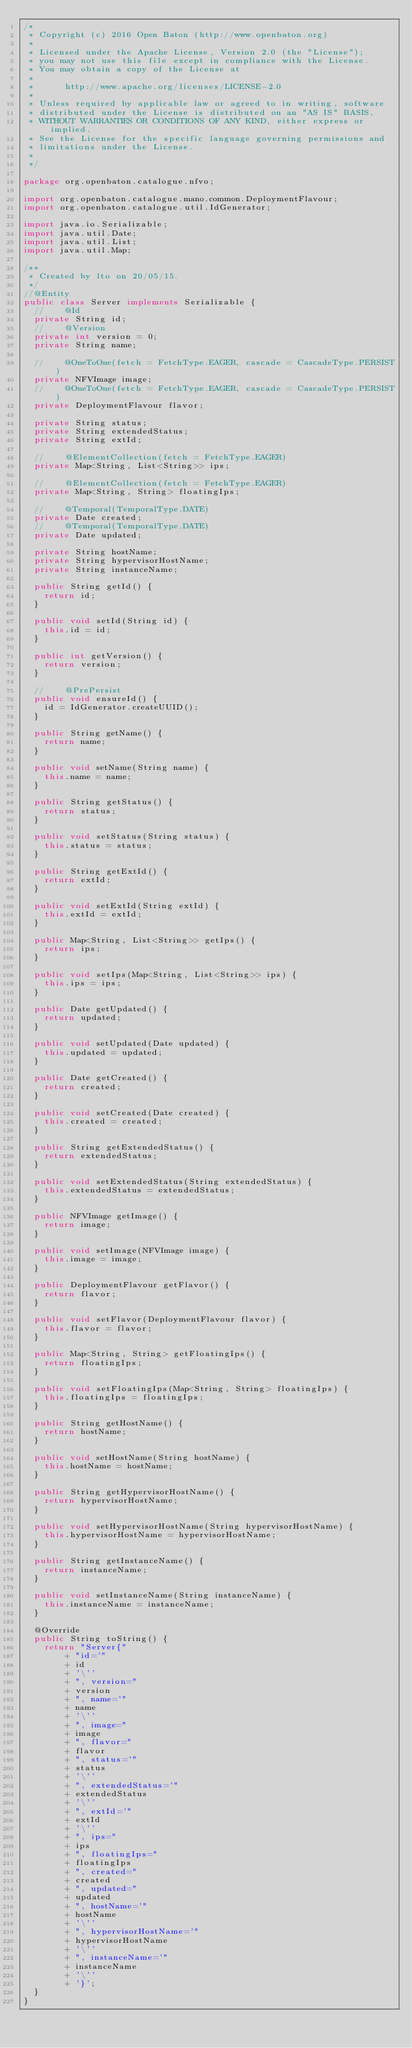<code> <loc_0><loc_0><loc_500><loc_500><_Java_>/*
 * Copyright (c) 2016 Open Baton (http://www.openbaton.org)
 *
 * Licensed under the Apache License, Version 2.0 (the "License");
 * you may not use this file except in compliance with the License.
 * You may obtain a copy of the License at
 *
 *      http://www.apache.org/licenses/LICENSE-2.0
 *
 * Unless required by applicable law or agreed to in writing, software
 * distributed under the License is distributed on an "AS IS" BASIS,
 * WITHOUT WARRANTIES OR CONDITIONS OF ANY KIND, either express or implied.
 * See the License for the specific language governing permissions and
 * limitations under the License.
 *
 */

package org.openbaton.catalogue.nfvo;

import org.openbaton.catalogue.mano.common.DeploymentFlavour;
import org.openbaton.catalogue.util.IdGenerator;

import java.io.Serializable;
import java.util.Date;
import java.util.List;
import java.util.Map;

/**
 * Created by lto on 20/05/15.
 */
//@Entity
public class Server implements Serializable {
  //    @Id
  private String id;
  //    @Version
  private int version = 0;
  private String name;

  //    @OneToOne(fetch = FetchType.EAGER, cascade = CascadeType.PERSIST)
  private NFVImage image;
  //    @OneToOne(fetch = FetchType.EAGER, cascade = CascadeType.PERSIST)
  private DeploymentFlavour flavor;

  private String status;
  private String extendedStatus;
  private String extId;

  //    @ElementCollection(fetch = FetchType.EAGER)
  private Map<String, List<String>> ips;

  //    @ElementCollection(fetch = FetchType.EAGER)
  private Map<String, String> floatingIps;

  //    @Temporal(TemporalType.DATE)
  private Date created;
  //    @Temporal(TemporalType.DATE)
  private Date updated;

  private String hostName;
  private String hypervisorHostName;
  private String instanceName;

  public String getId() {
    return id;
  }

  public void setId(String id) {
    this.id = id;
  }

  public int getVersion() {
    return version;
  }

  //    @PrePersist
  public void ensureId() {
    id = IdGenerator.createUUID();
  }

  public String getName() {
    return name;
  }

  public void setName(String name) {
    this.name = name;
  }

  public String getStatus() {
    return status;
  }

  public void setStatus(String status) {
    this.status = status;
  }

  public String getExtId() {
    return extId;
  }

  public void setExtId(String extId) {
    this.extId = extId;
  }

  public Map<String, List<String>> getIps() {
    return ips;
  }

  public void setIps(Map<String, List<String>> ips) {
    this.ips = ips;
  }

  public Date getUpdated() {
    return updated;
  }

  public void setUpdated(Date updated) {
    this.updated = updated;
  }

  public Date getCreated() {
    return created;
  }

  public void setCreated(Date created) {
    this.created = created;
  }

  public String getExtendedStatus() {
    return extendedStatus;
  }

  public void setExtendedStatus(String extendedStatus) {
    this.extendedStatus = extendedStatus;
  }

  public NFVImage getImage() {
    return image;
  }

  public void setImage(NFVImage image) {
    this.image = image;
  }

  public DeploymentFlavour getFlavor() {
    return flavor;
  }

  public void setFlavor(DeploymentFlavour flavor) {
    this.flavor = flavor;
  }

  public Map<String, String> getFloatingIps() {
    return floatingIps;
  }

  public void setFloatingIps(Map<String, String> floatingIps) {
    this.floatingIps = floatingIps;
  }

  public String getHostName() {
    return hostName;
  }

  public void setHostName(String hostName) {
    this.hostName = hostName;
  }

  public String getHypervisorHostName() {
    return hypervisorHostName;
  }

  public void setHypervisorHostName(String hypervisorHostName) {
    this.hypervisorHostName = hypervisorHostName;
  }

  public String getInstanceName() {
    return instanceName;
  }

  public void setInstanceName(String instanceName) {
    this.instanceName = instanceName;
  }

  @Override
  public String toString() {
    return "Server{"
        + "id='"
        + id
        + '\''
        + ", version="
        + version
        + ", name='"
        + name
        + '\''
        + ", image="
        + image
        + ", flavor="
        + flavor
        + ", status='"
        + status
        + '\''
        + ", extendedStatus='"
        + extendedStatus
        + '\''
        + ", extId='"
        + extId
        + '\''
        + ", ips="
        + ips
        + ", floatingIps="
        + floatingIps
        + ", created="
        + created
        + ", updated="
        + updated
        + ", hostName='"
        + hostName
        + '\''
        + ", hypervisorHostName='"
        + hypervisorHostName
        + '\''
        + ", instanceName='"
        + instanceName
        + '\''
        + '}';
  }
}
</code> 